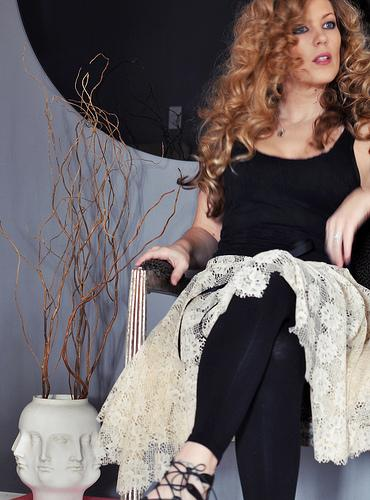What is the position of the woman's hand in the image, and what is she interacting with? Her hand is on an armrest of the chair she is sitting in. Identify the color and any unique features of the vase in the image. The vase is white and has faces sculpted into it, with brown curly sticks inside sans leaves. How many different types of fabric or material are depicted in the image, and what are they? Three types: the woman's black shirt/tank top, white skirt, and the white lace material draped on her knees. What is the main color of the background and what is the central secondary object in the scene? The main color of the background is blue, with a large round mirror on the wall as a central secondary object. Describe any interaction between the woman and the background elements in the image. The woman is sitting on a chair with her hand on the armrest, with the blue wall and a shadow on the wall beneath the chair as background elements. Can you provide a quick summary of the primary objects in this image? A woman with curly hair, wearing a black shirt and white skirt, is sitting with legs crossed at the knees, adorned with a lace shawl. A white vase with faces and curly sticks inside is placed beside her. Please list three important characteristics of the woman's appearance. The woman has very long curly hair, she is wearing a black tank top and a white skirt, and she has on a necklace. Examine the woman's makeup and jewelry. What do you notice? The woman is wearing eye makeup, pink lips and white teeth are visible, and she is wearing a necklace and a ring. Enumerate all the elements in the image related to the woman's attire. Black tank top, white skirt, black tights or leggings, black lace-up shoes, necklace, and ring. What type of shoes does the woman in the image have on? The woman is wearing black lace-up shoes that tie at the ankle. 